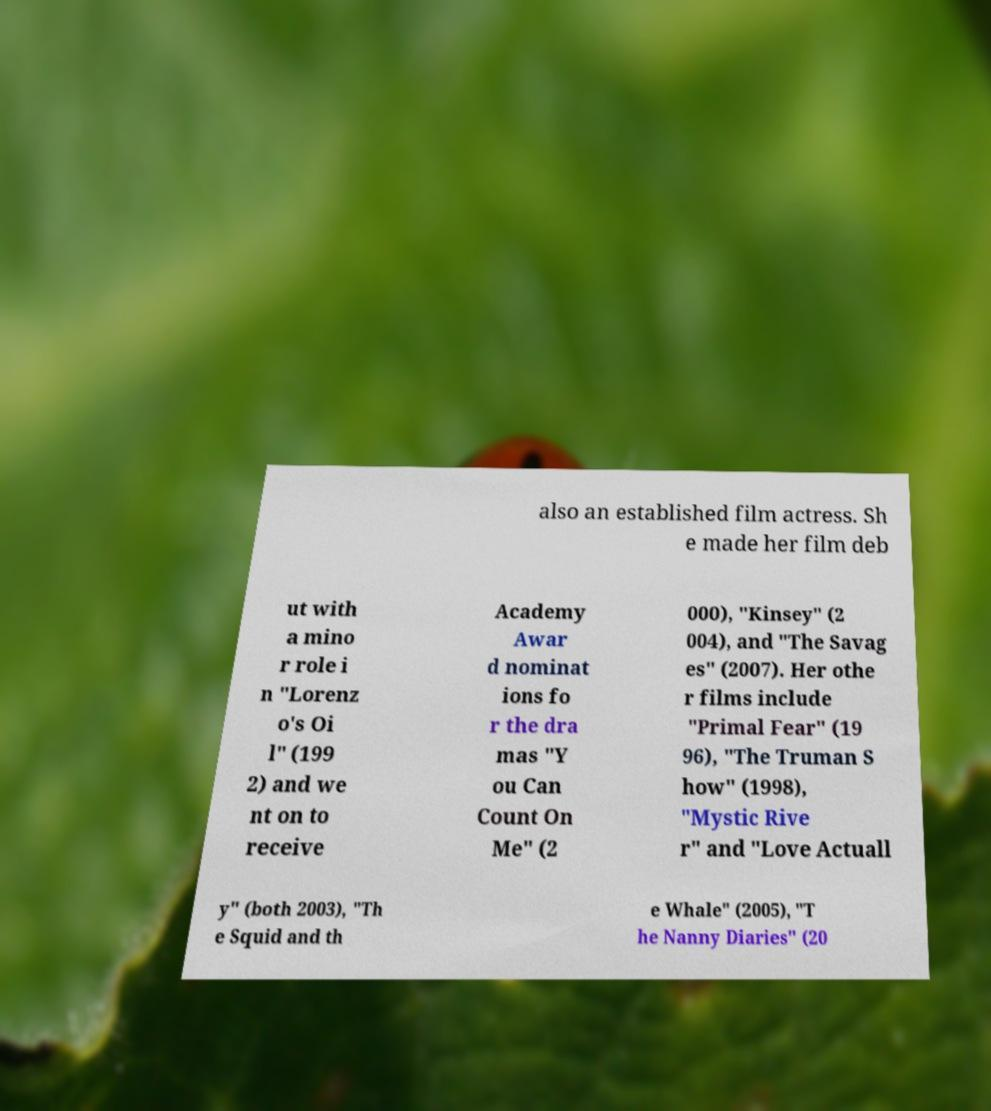Can you read and provide the text displayed in the image?This photo seems to have some interesting text. Can you extract and type it out for me? also an established film actress. Sh e made her film deb ut with a mino r role i n "Lorenz o's Oi l" (199 2) and we nt on to receive Academy Awar d nominat ions fo r the dra mas "Y ou Can Count On Me" (2 000), "Kinsey" (2 004), and "The Savag es" (2007). Her othe r films include "Primal Fear" (19 96), "The Truman S how" (1998), "Mystic Rive r" and "Love Actuall y" (both 2003), "Th e Squid and th e Whale" (2005), "T he Nanny Diaries" (20 